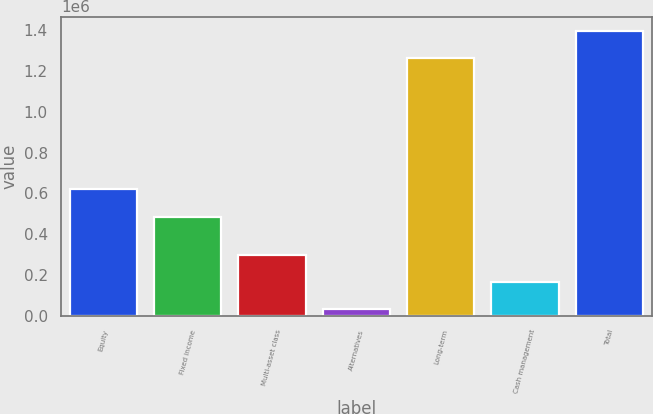<chart> <loc_0><loc_0><loc_500><loc_500><bar_chart><fcel>Equity<fcel>Fixed income<fcel>Multi-asset class<fcel>Alternatives<fcel>Long-term<fcel>Cash management<fcel>Total<nl><fcel>622744<fcel>485388<fcel>298316<fcel>35855<fcel>1.26435e+06<fcel>167086<fcel>1.39558e+06<nl></chart> 